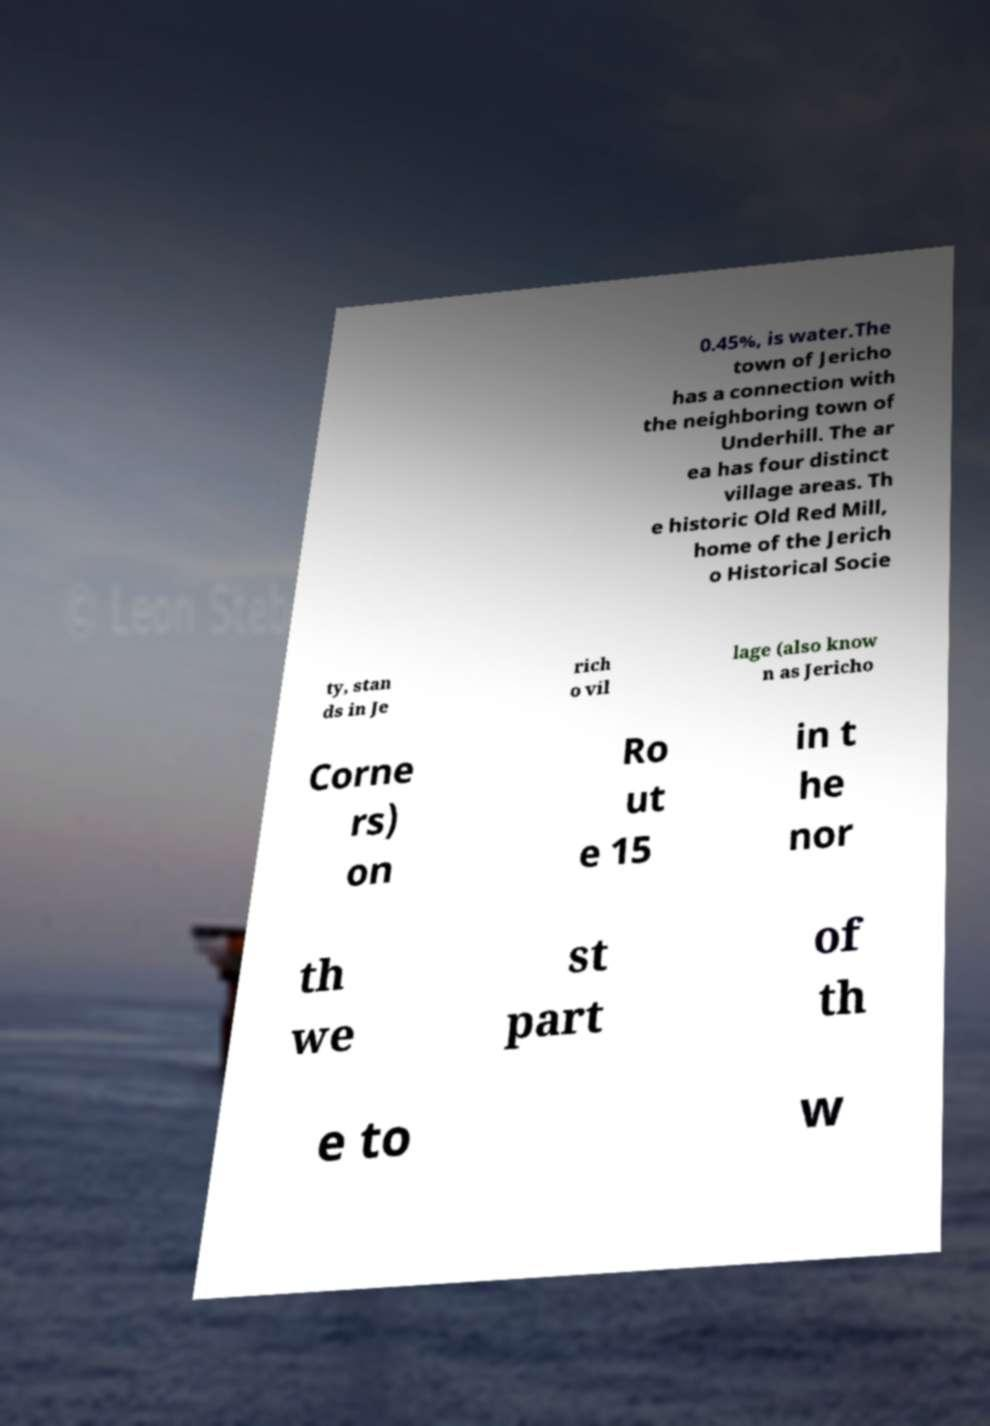Can you accurately transcribe the text from the provided image for me? 0.45%, is water.The town of Jericho has a connection with the neighboring town of Underhill. The ar ea has four distinct village areas. Th e historic Old Red Mill, home of the Jerich o Historical Socie ty, stan ds in Je rich o vil lage (also know n as Jericho Corne rs) on Ro ut e 15 in t he nor th we st part of th e to w 